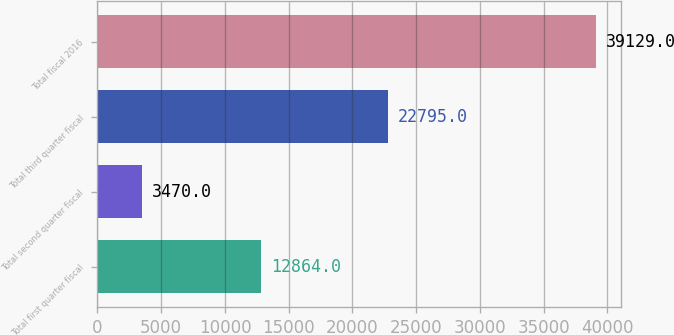<chart> <loc_0><loc_0><loc_500><loc_500><bar_chart><fcel>Total first quarter fiscal<fcel>Total second quarter fiscal<fcel>Total third quarter fiscal<fcel>Total fiscal 2016<nl><fcel>12864<fcel>3470<fcel>22795<fcel>39129<nl></chart> 